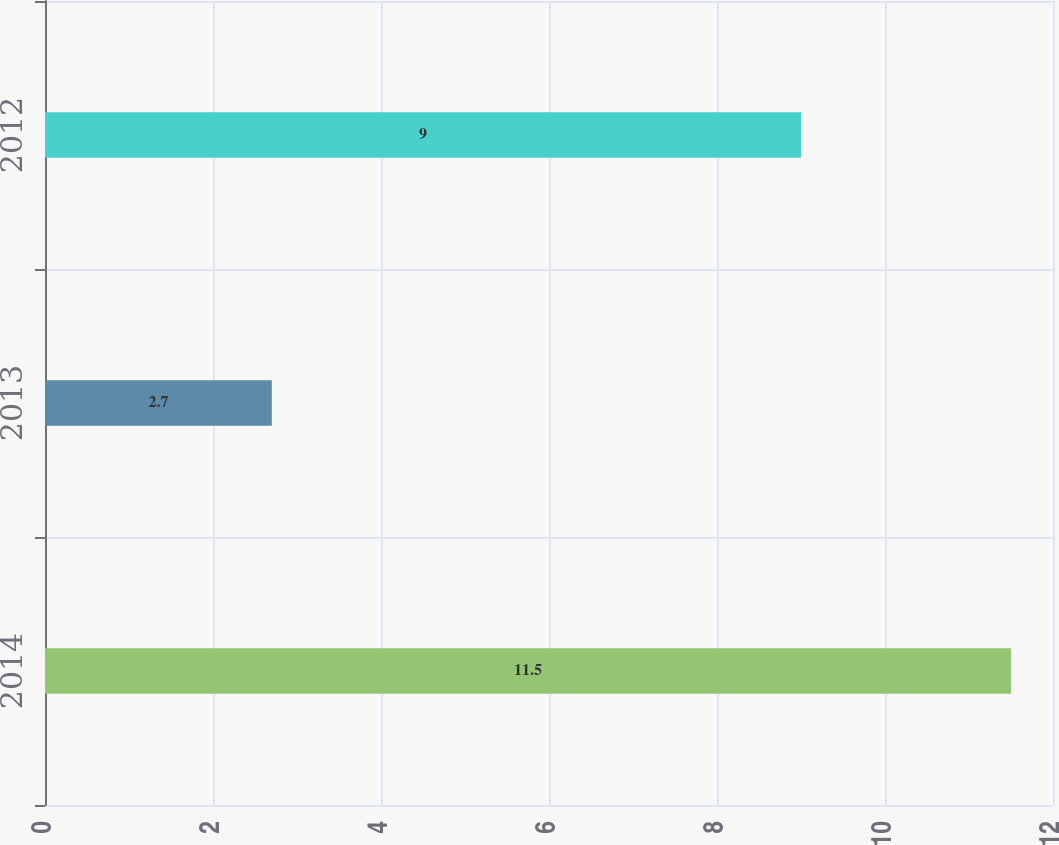Convert chart. <chart><loc_0><loc_0><loc_500><loc_500><bar_chart><fcel>2014<fcel>2013<fcel>2012<nl><fcel>11.5<fcel>2.7<fcel>9<nl></chart> 